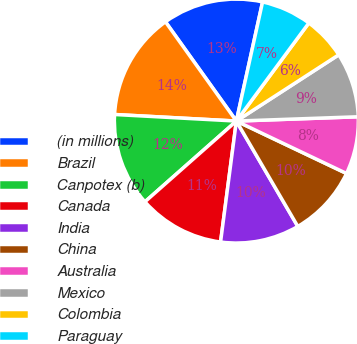Convert chart to OTSL. <chart><loc_0><loc_0><loc_500><loc_500><pie_chart><fcel>(in millions)<fcel>Brazil<fcel>Canpotex (b)<fcel>Canada<fcel>India<fcel>China<fcel>Australia<fcel>Mexico<fcel>Colombia<fcel>Paraguay<nl><fcel>13.32%<fcel>14.27%<fcel>12.37%<fcel>11.42%<fcel>10.47%<fcel>9.53%<fcel>7.63%<fcel>8.58%<fcel>5.73%<fcel>6.68%<nl></chart> 